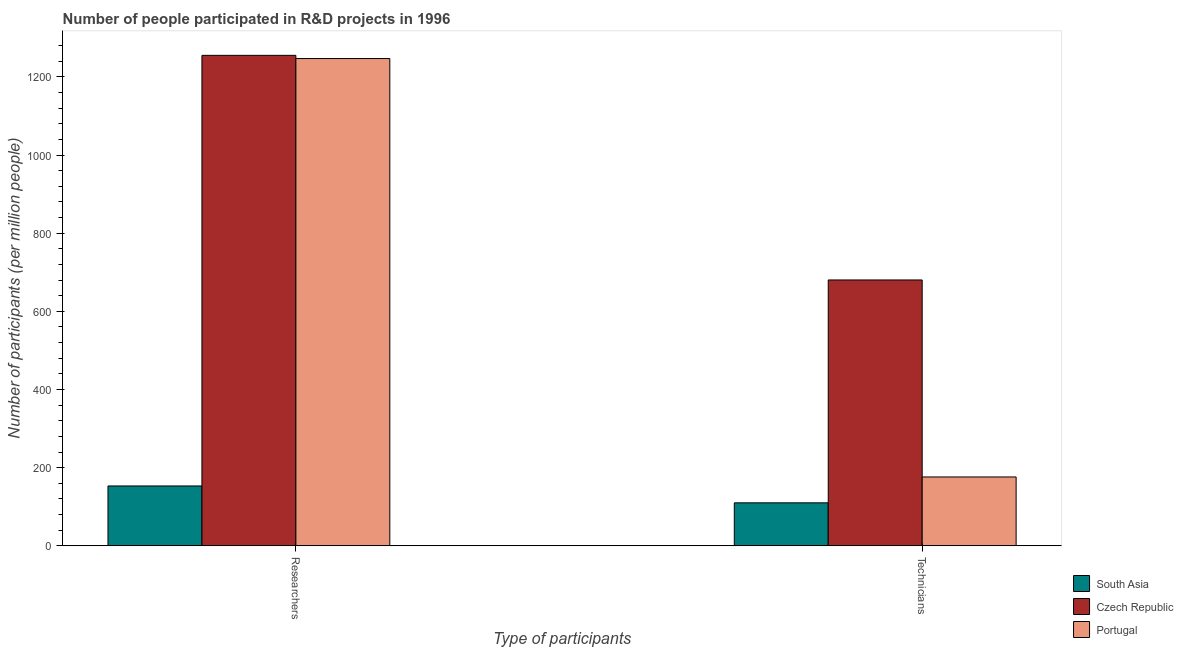How many different coloured bars are there?
Your answer should be very brief. 3. How many groups of bars are there?
Give a very brief answer. 2. How many bars are there on the 1st tick from the left?
Make the answer very short. 3. How many bars are there on the 1st tick from the right?
Keep it short and to the point. 3. What is the label of the 2nd group of bars from the left?
Keep it short and to the point. Technicians. What is the number of researchers in Portugal?
Your answer should be compact. 1247.11. Across all countries, what is the maximum number of technicians?
Offer a terse response. 680.37. Across all countries, what is the minimum number of technicians?
Your response must be concise. 109.91. In which country was the number of technicians maximum?
Provide a short and direct response. Czech Republic. In which country was the number of researchers minimum?
Give a very brief answer. South Asia. What is the total number of technicians in the graph?
Keep it short and to the point. 966.44. What is the difference between the number of researchers in South Asia and that in Czech Republic?
Provide a succinct answer. -1102.16. What is the difference between the number of technicians in Portugal and the number of researchers in Czech Republic?
Provide a succinct answer. -1079.14. What is the average number of researchers per country?
Make the answer very short. 885.18. What is the difference between the number of technicians and number of researchers in South Asia?
Provide a short and direct response. -43.22. What is the ratio of the number of technicians in South Asia to that in Portugal?
Offer a very short reply. 0.62. What does the 2nd bar from the left in Researchers represents?
Keep it short and to the point. Czech Republic. How many countries are there in the graph?
Offer a very short reply. 3. What is the difference between two consecutive major ticks on the Y-axis?
Your response must be concise. 200. Are the values on the major ticks of Y-axis written in scientific E-notation?
Your answer should be very brief. No. Does the graph contain grids?
Provide a succinct answer. No. Where does the legend appear in the graph?
Provide a succinct answer. Bottom right. How are the legend labels stacked?
Your answer should be compact. Vertical. What is the title of the graph?
Provide a short and direct response. Number of people participated in R&D projects in 1996. What is the label or title of the X-axis?
Give a very brief answer. Type of participants. What is the label or title of the Y-axis?
Offer a very short reply. Number of participants (per million people). What is the Number of participants (per million people) in South Asia in Researchers?
Make the answer very short. 153.13. What is the Number of participants (per million people) in Czech Republic in Researchers?
Your response must be concise. 1255.29. What is the Number of participants (per million people) of Portugal in Researchers?
Your response must be concise. 1247.11. What is the Number of participants (per million people) of South Asia in Technicians?
Give a very brief answer. 109.91. What is the Number of participants (per million people) in Czech Republic in Technicians?
Offer a terse response. 680.37. What is the Number of participants (per million people) of Portugal in Technicians?
Your answer should be compact. 176.15. Across all Type of participants, what is the maximum Number of participants (per million people) in South Asia?
Make the answer very short. 153.13. Across all Type of participants, what is the maximum Number of participants (per million people) in Czech Republic?
Provide a succinct answer. 1255.29. Across all Type of participants, what is the maximum Number of participants (per million people) in Portugal?
Your answer should be very brief. 1247.11. Across all Type of participants, what is the minimum Number of participants (per million people) in South Asia?
Keep it short and to the point. 109.91. Across all Type of participants, what is the minimum Number of participants (per million people) of Czech Republic?
Keep it short and to the point. 680.37. Across all Type of participants, what is the minimum Number of participants (per million people) in Portugal?
Provide a succinct answer. 176.15. What is the total Number of participants (per million people) of South Asia in the graph?
Your answer should be very brief. 263.04. What is the total Number of participants (per million people) of Czech Republic in the graph?
Offer a terse response. 1935.67. What is the total Number of participants (per million people) of Portugal in the graph?
Your answer should be very brief. 1423.27. What is the difference between the Number of participants (per million people) in South Asia in Researchers and that in Technicians?
Your answer should be compact. 43.22. What is the difference between the Number of participants (per million people) in Czech Republic in Researchers and that in Technicians?
Offer a terse response. 574.92. What is the difference between the Number of participants (per million people) of Portugal in Researchers and that in Technicians?
Make the answer very short. 1070.96. What is the difference between the Number of participants (per million people) in South Asia in Researchers and the Number of participants (per million people) in Czech Republic in Technicians?
Keep it short and to the point. -527.24. What is the difference between the Number of participants (per million people) of South Asia in Researchers and the Number of participants (per million people) of Portugal in Technicians?
Your response must be concise. -23.02. What is the difference between the Number of participants (per million people) in Czech Republic in Researchers and the Number of participants (per million people) in Portugal in Technicians?
Provide a succinct answer. 1079.14. What is the average Number of participants (per million people) of South Asia per Type of participants?
Give a very brief answer. 131.52. What is the average Number of participants (per million people) of Czech Republic per Type of participants?
Provide a short and direct response. 967.83. What is the average Number of participants (per million people) of Portugal per Type of participants?
Make the answer very short. 711.63. What is the difference between the Number of participants (per million people) of South Asia and Number of participants (per million people) of Czech Republic in Researchers?
Provide a short and direct response. -1102.16. What is the difference between the Number of participants (per million people) in South Asia and Number of participants (per million people) in Portugal in Researchers?
Offer a very short reply. -1093.98. What is the difference between the Number of participants (per million people) in Czech Republic and Number of participants (per million people) in Portugal in Researchers?
Provide a short and direct response. 8.18. What is the difference between the Number of participants (per million people) of South Asia and Number of participants (per million people) of Czech Republic in Technicians?
Your response must be concise. -570.46. What is the difference between the Number of participants (per million people) in South Asia and Number of participants (per million people) in Portugal in Technicians?
Your answer should be very brief. -66.24. What is the difference between the Number of participants (per million people) in Czech Republic and Number of participants (per million people) in Portugal in Technicians?
Your answer should be compact. 504.22. What is the ratio of the Number of participants (per million people) of South Asia in Researchers to that in Technicians?
Your answer should be compact. 1.39. What is the ratio of the Number of participants (per million people) of Czech Republic in Researchers to that in Technicians?
Keep it short and to the point. 1.84. What is the ratio of the Number of participants (per million people) of Portugal in Researchers to that in Technicians?
Offer a very short reply. 7.08. What is the difference between the highest and the second highest Number of participants (per million people) in South Asia?
Offer a terse response. 43.22. What is the difference between the highest and the second highest Number of participants (per million people) in Czech Republic?
Your answer should be very brief. 574.92. What is the difference between the highest and the second highest Number of participants (per million people) of Portugal?
Provide a succinct answer. 1070.96. What is the difference between the highest and the lowest Number of participants (per million people) in South Asia?
Offer a terse response. 43.22. What is the difference between the highest and the lowest Number of participants (per million people) in Czech Republic?
Provide a short and direct response. 574.92. What is the difference between the highest and the lowest Number of participants (per million people) in Portugal?
Your answer should be compact. 1070.96. 